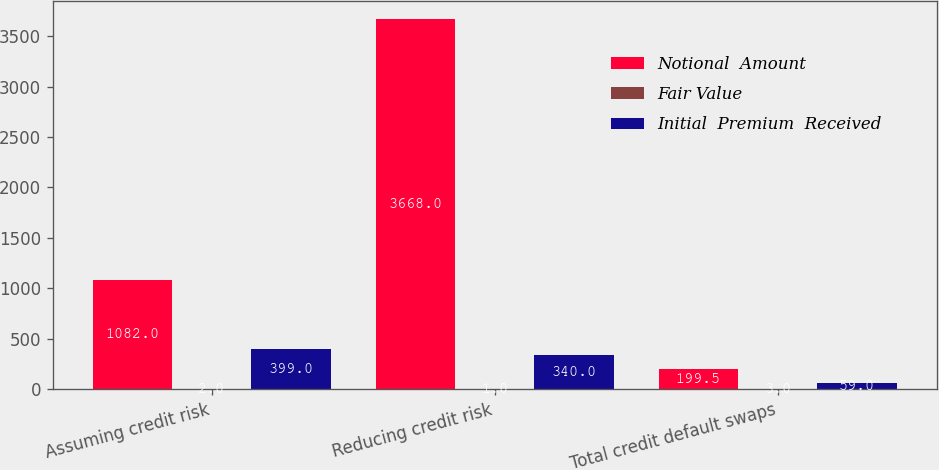Convert chart to OTSL. <chart><loc_0><loc_0><loc_500><loc_500><stacked_bar_chart><ecel><fcel>Assuming credit risk<fcel>Reducing credit risk<fcel>Total credit default swaps<nl><fcel>Notional  Amount<fcel>1082<fcel>3668<fcel>199.5<nl><fcel>Fair Value<fcel>2<fcel>1<fcel>3<nl><fcel>Initial  Premium  Received<fcel>399<fcel>340<fcel>59<nl></chart> 